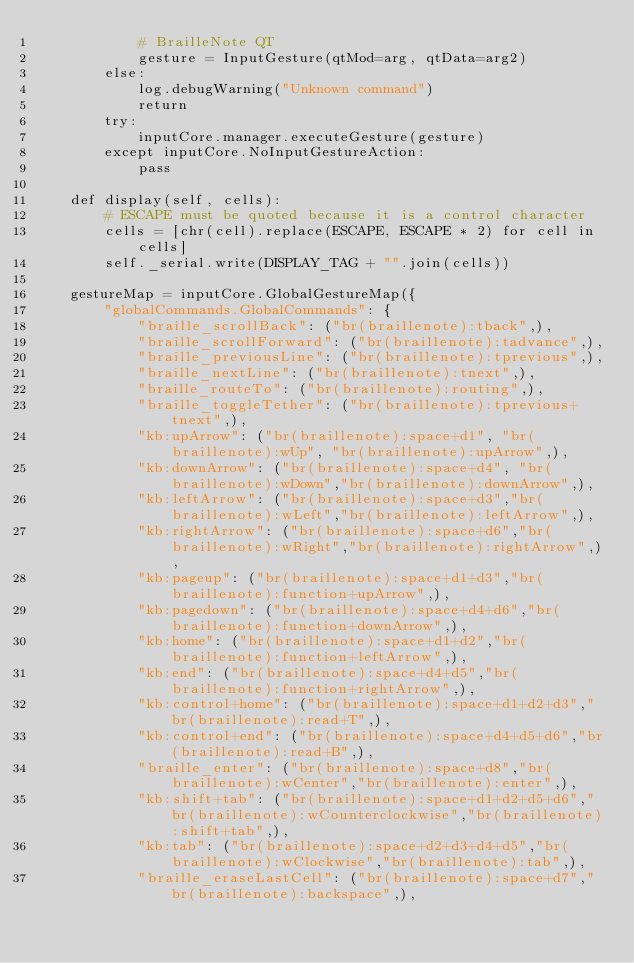<code> <loc_0><loc_0><loc_500><loc_500><_Python_>			# BrailleNote QT
			gesture = InputGesture(qtMod=arg, qtData=arg2)
		else:
			log.debugWarning("Unknown command")
			return
		try:
			inputCore.manager.executeGesture(gesture)
		except inputCore.NoInputGestureAction:
			pass

	def display(self, cells):
		# ESCAPE must be quoted because it is a control character
		cells = [chr(cell).replace(ESCAPE, ESCAPE * 2) for cell in cells]
		self._serial.write(DISPLAY_TAG + "".join(cells))

	gestureMap = inputCore.GlobalGestureMap({
		"globalCommands.GlobalCommands": {
			"braille_scrollBack": ("br(braillenote):tback",),
			"braille_scrollForward": ("br(braillenote):tadvance",),
			"braille_previousLine": ("br(braillenote):tprevious",),
			"braille_nextLine": ("br(braillenote):tnext",),
			"braille_routeTo": ("br(braillenote):routing",),
			"braille_toggleTether": ("br(braillenote):tprevious+tnext",),
			"kb:upArrow": ("br(braillenote):space+d1", "br(braillenote):wUp", "br(braillenote):upArrow",),
			"kb:downArrow": ("br(braillenote):space+d4", "br(braillenote):wDown","br(braillenote):downArrow",),
			"kb:leftArrow": ("br(braillenote):space+d3","br(braillenote):wLeft","br(braillenote):leftArrow",),
			"kb:rightArrow": ("br(braillenote):space+d6","br(braillenote):wRight","br(braillenote):rightArrow",),
			"kb:pageup": ("br(braillenote):space+d1+d3","br(braillenote):function+upArrow",),
			"kb:pagedown": ("br(braillenote):space+d4+d6","br(braillenote):function+downArrow",),
			"kb:home": ("br(braillenote):space+d1+d2","br(braillenote):function+leftArrow",),
			"kb:end": ("br(braillenote):space+d4+d5","br(braillenote):function+rightArrow",),
			"kb:control+home": ("br(braillenote):space+d1+d2+d3","br(braillenote):read+T",),
			"kb:control+end": ("br(braillenote):space+d4+d5+d6","br(braillenote):read+B",),
			"braille_enter": ("br(braillenote):space+d8","br(braillenote):wCenter","br(braillenote):enter",),
			"kb:shift+tab": ("br(braillenote):space+d1+d2+d5+d6","br(braillenote):wCounterclockwise","br(braillenote):shift+tab",),
			"kb:tab": ("br(braillenote):space+d2+d3+d4+d5","br(braillenote):wClockwise","br(braillenote):tab",),
			"braille_eraseLastCell": ("br(braillenote):space+d7","br(braillenote):backspace",),</code> 